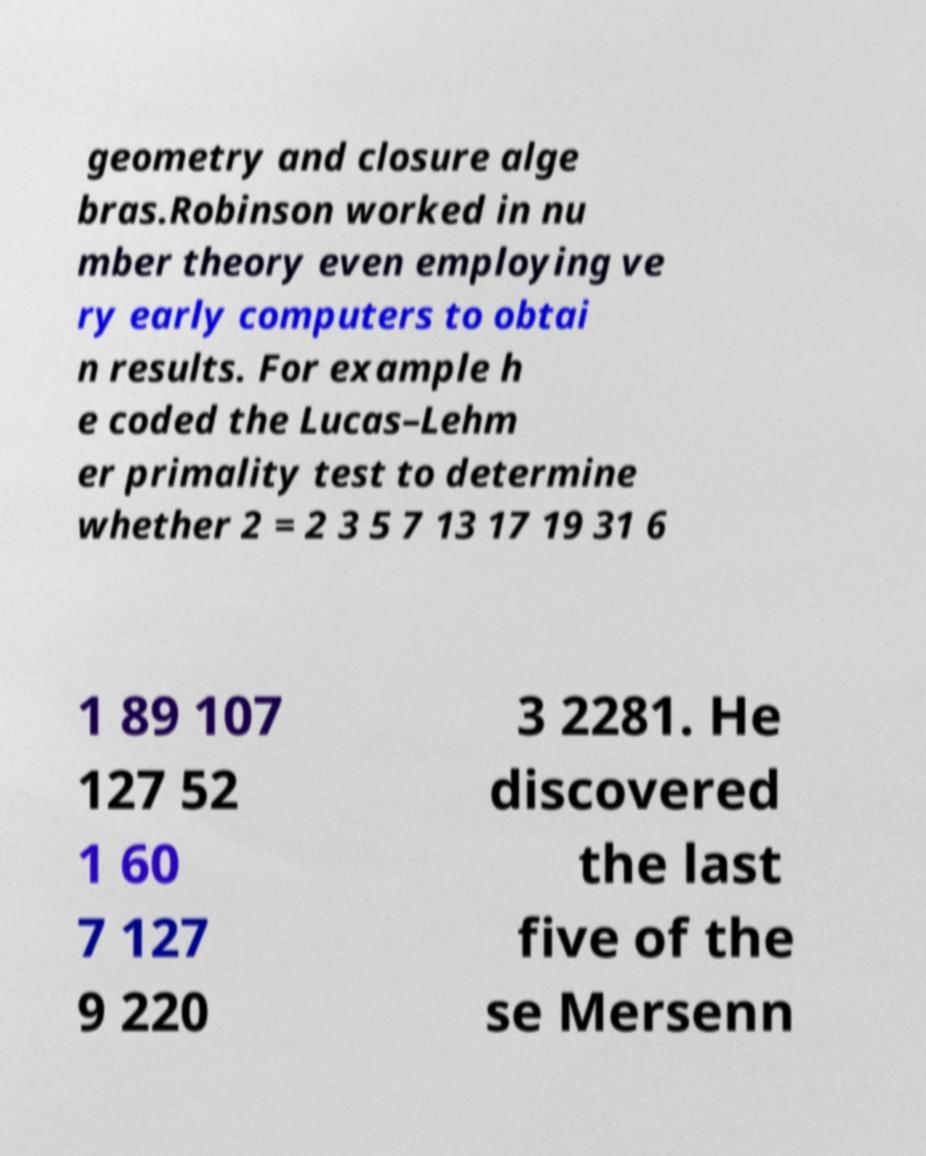For documentation purposes, I need the text within this image transcribed. Could you provide that? geometry and closure alge bras.Robinson worked in nu mber theory even employing ve ry early computers to obtai n results. For example h e coded the Lucas–Lehm er primality test to determine whether 2 = 2 3 5 7 13 17 19 31 6 1 89 107 127 52 1 60 7 127 9 220 3 2281. He discovered the last five of the se Mersenn 